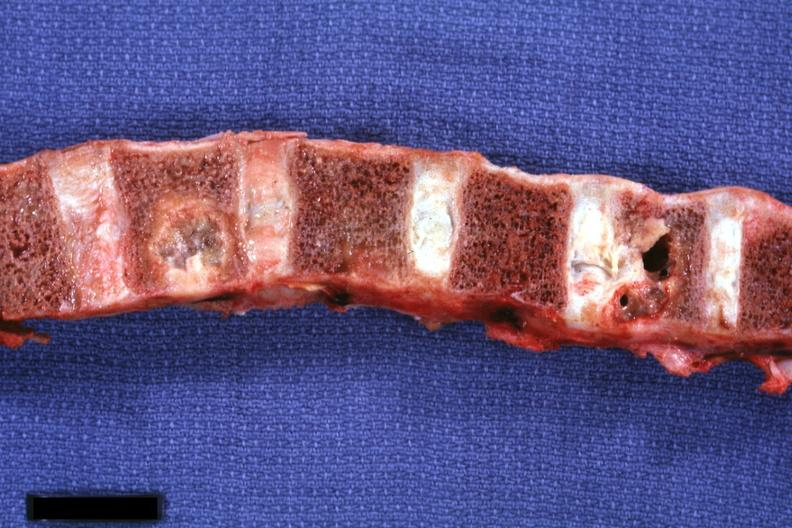how is vertebral bodies showing very nicely metastatic lesions primary squamous cell carcinoma penis?
Answer the question using a single word or phrase. Osteolytic 